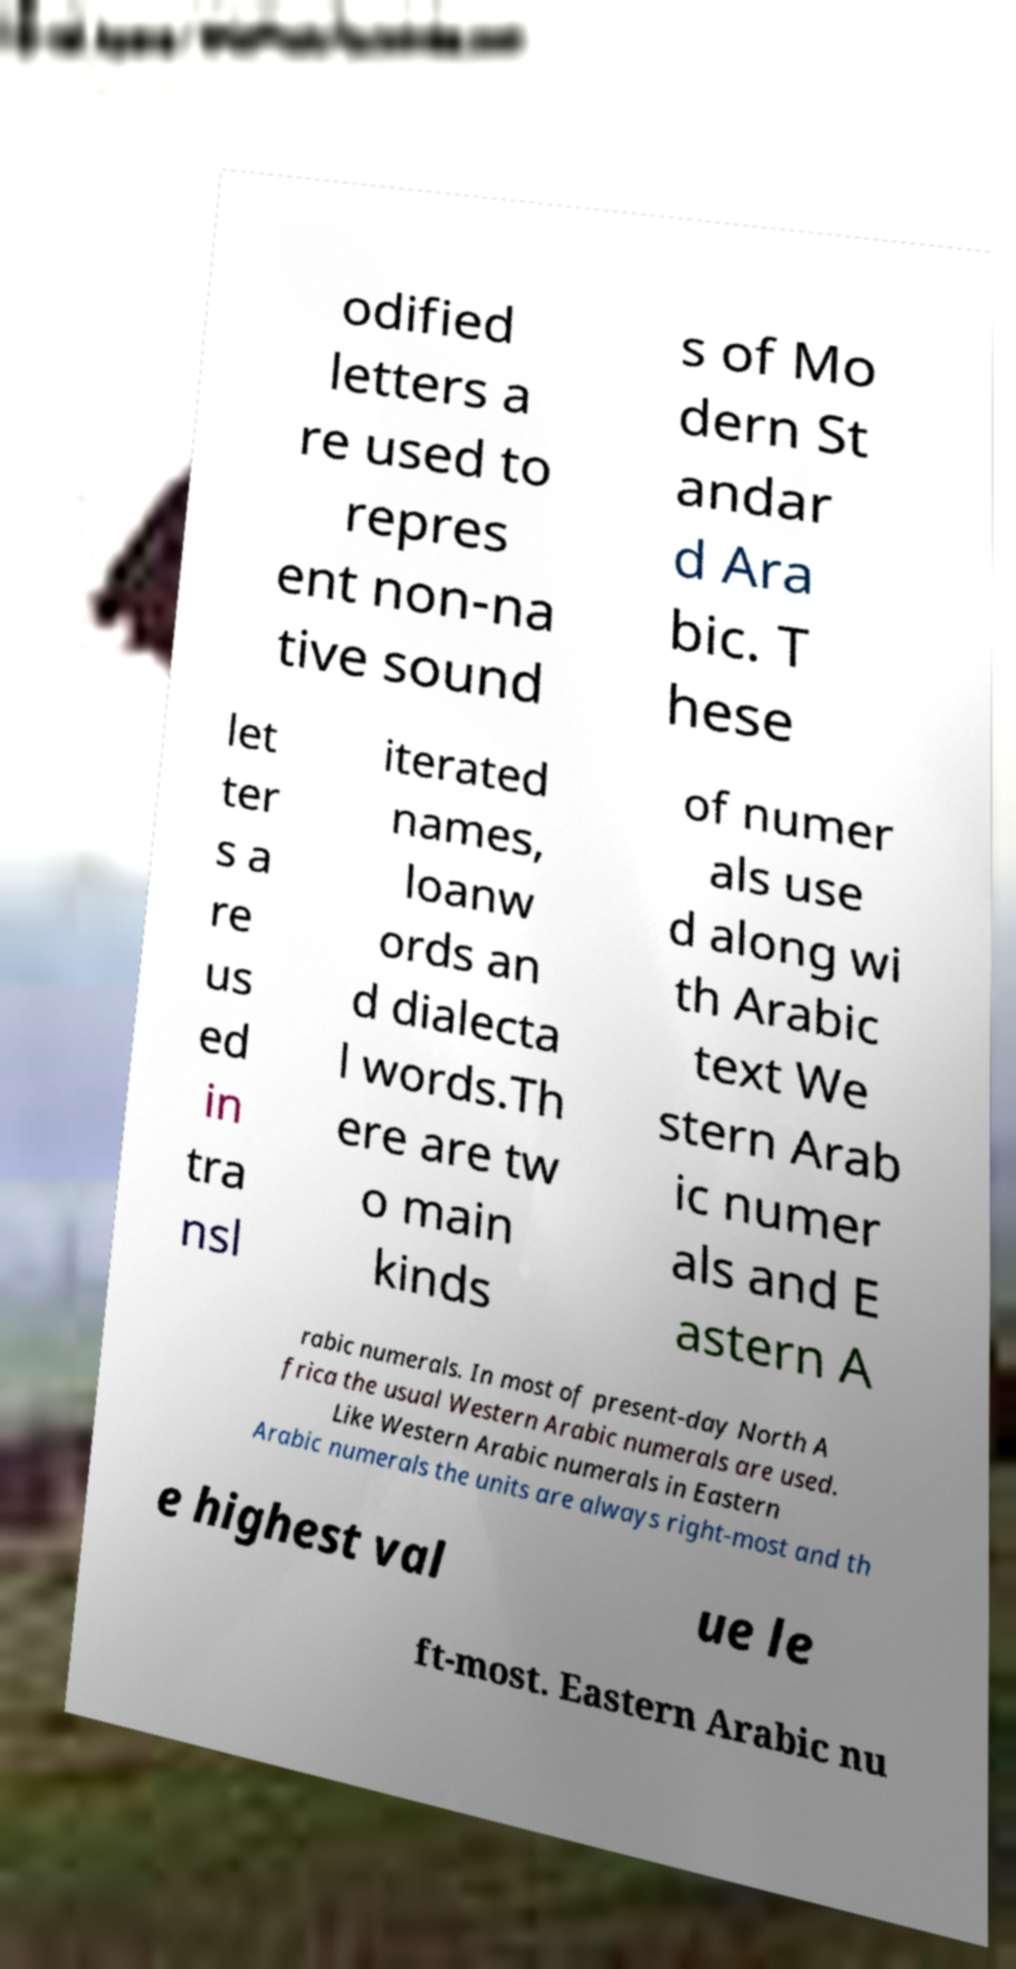I need the written content from this picture converted into text. Can you do that? odified letters a re used to repres ent non-na tive sound s of Mo dern St andar d Ara bic. T hese let ter s a re us ed in tra nsl iterated names, loanw ords an d dialecta l words.Th ere are tw o main kinds of numer als use d along wi th Arabic text We stern Arab ic numer als and E astern A rabic numerals. In most of present-day North A frica the usual Western Arabic numerals are used. Like Western Arabic numerals in Eastern Arabic numerals the units are always right-most and th e highest val ue le ft-most. Eastern Arabic nu 